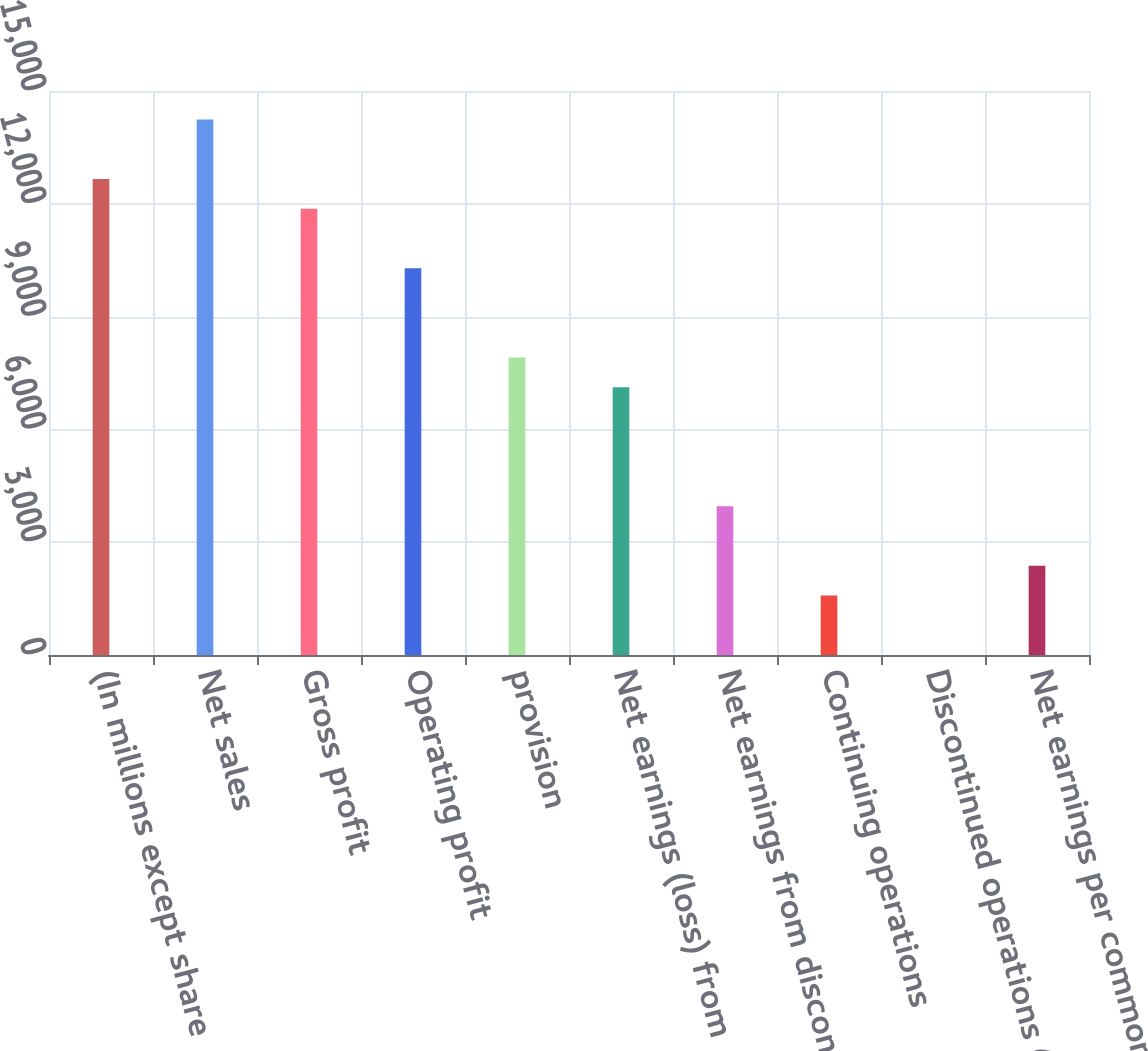<chart> <loc_0><loc_0><loc_500><loc_500><bar_chart><fcel>(In millions except share<fcel>Net sales<fcel>Gross profit<fcel>Operating profit<fcel>provision<fcel>Net earnings (loss) from<fcel>Net earnings from discontinued<fcel>Continuing operations<fcel>Discontinued operations (1)(2)<fcel>Net earnings per common<nl><fcel>12659<fcel>14241.3<fcel>11867.8<fcel>10285.5<fcel>7912.03<fcel>7120.87<fcel>3956.23<fcel>1582.75<fcel>0.43<fcel>2373.91<nl></chart> 